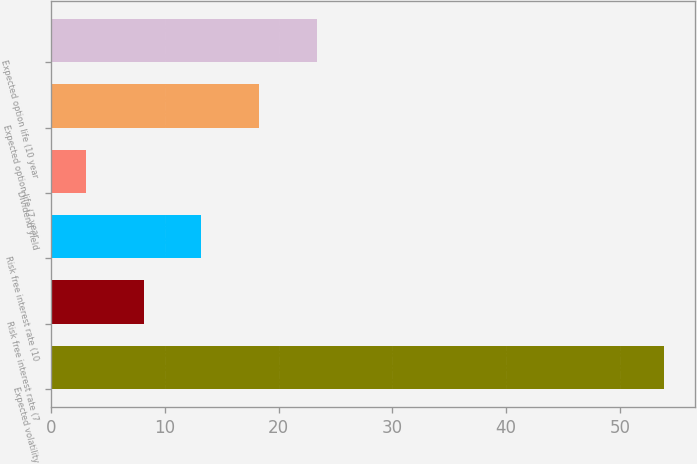Convert chart to OTSL. <chart><loc_0><loc_0><loc_500><loc_500><bar_chart><fcel>Expected volatility<fcel>Risk free interest rate (7<fcel>Risk free interest rate (10<fcel>Dividend yield<fcel>Expected option life (7 year<fcel>Expected option life (10 year<nl><fcel>53.87<fcel>8.12<fcel>13.2<fcel>3.04<fcel>18.28<fcel>23.36<nl></chart> 